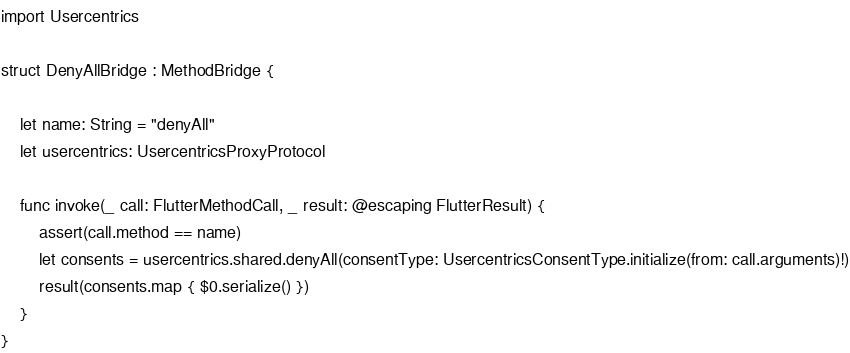Convert code to text. <code><loc_0><loc_0><loc_500><loc_500><_Swift_>import Usercentrics

struct DenyAllBridge : MethodBridge {

    let name: String = "denyAll"
    let usercentrics: UsercentricsProxyProtocol

    func invoke(_ call: FlutterMethodCall, _ result: @escaping FlutterResult) {
        assert(call.method == name)
        let consents = usercentrics.shared.denyAll(consentType: UsercentricsConsentType.initialize(from: call.arguments)!)
        result(consents.map { $0.serialize() })
    }
}
</code> 